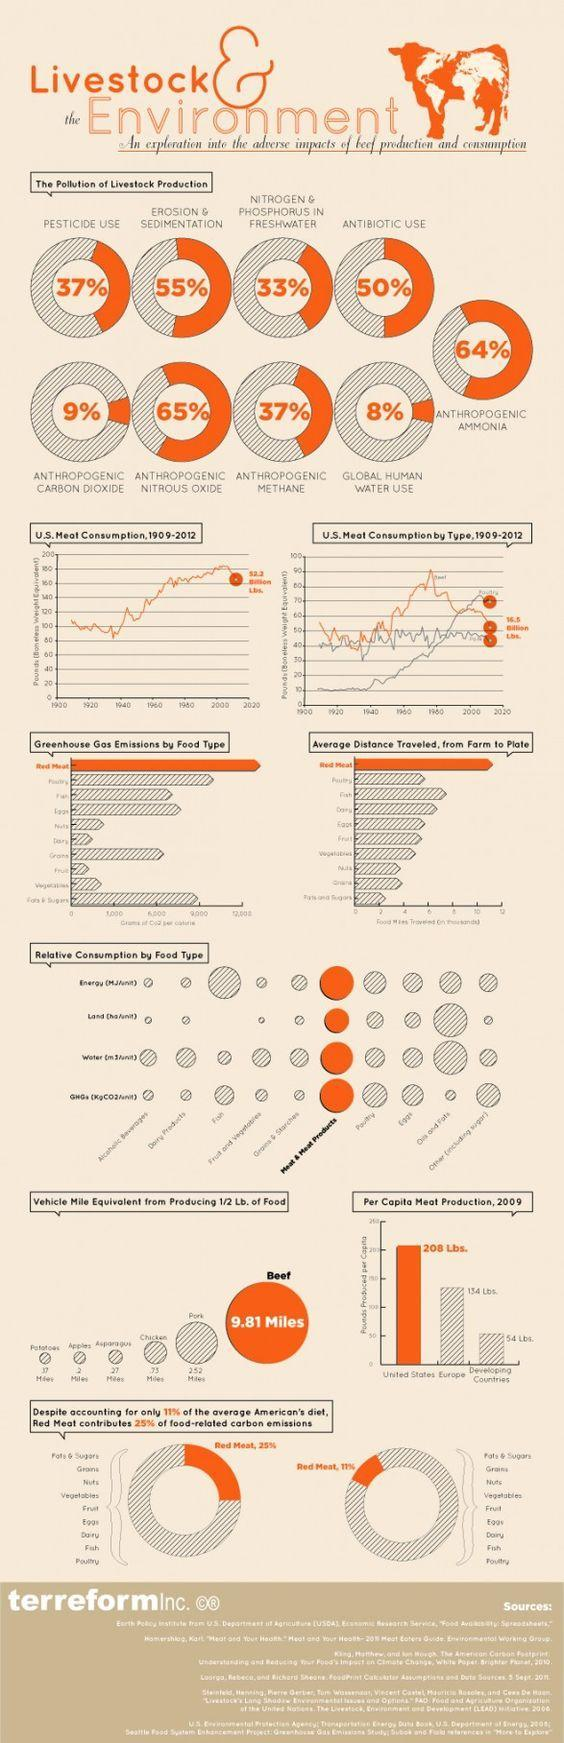Which food type consumes more energy, water, and greenhouse gases?
Answer the question with a short phrase. Meat & Meat Products Which food type has longest average distance travelled and the maximum carbon emissions? Red Meat What causes 50% pollution in livestock production? Antibiotic use What is the contribution of anthropogenic CH4 in polluting livestock production? 37% What food type has to travel the second longest distance to reach consumers? Pork 